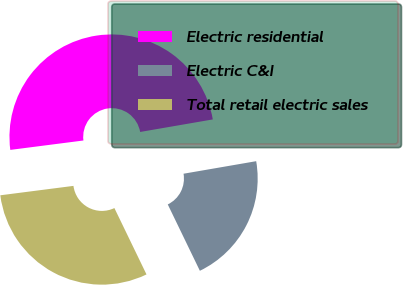Convert chart. <chart><loc_0><loc_0><loc_500><loc_500><pie_chart><fcel>Electric residential<fcel>Electric C&I<fcel>Total retail electric sales<nl><fcel>49.32%<fcel>20.55%<fcel>30.14%<nl></chart> 